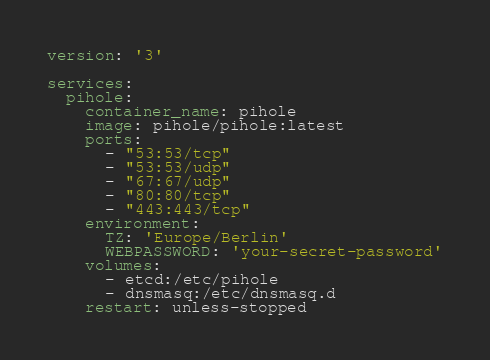<code> <loc_0><loc_0><loc_500><loc_500><_YAML_>version: '3'

services:
  pihole:
    container_name: pihole
    image: pihole/pihole:latest
    ports:
      - "53:53/tcp"
      - "53:53/udp"
      - "67:67/udp"
      - "80:80/tcp"
      - "443:443/tcp"
    environment:
      TZ: 'Europe/Berlin'
      WEBPASSWORD: 'your-secret-password'
    volumes:
      - etcd:/etc/pihole
      - dnsmasq:/etc/dnsmasq.d
    restart: unless-stopped</code> 